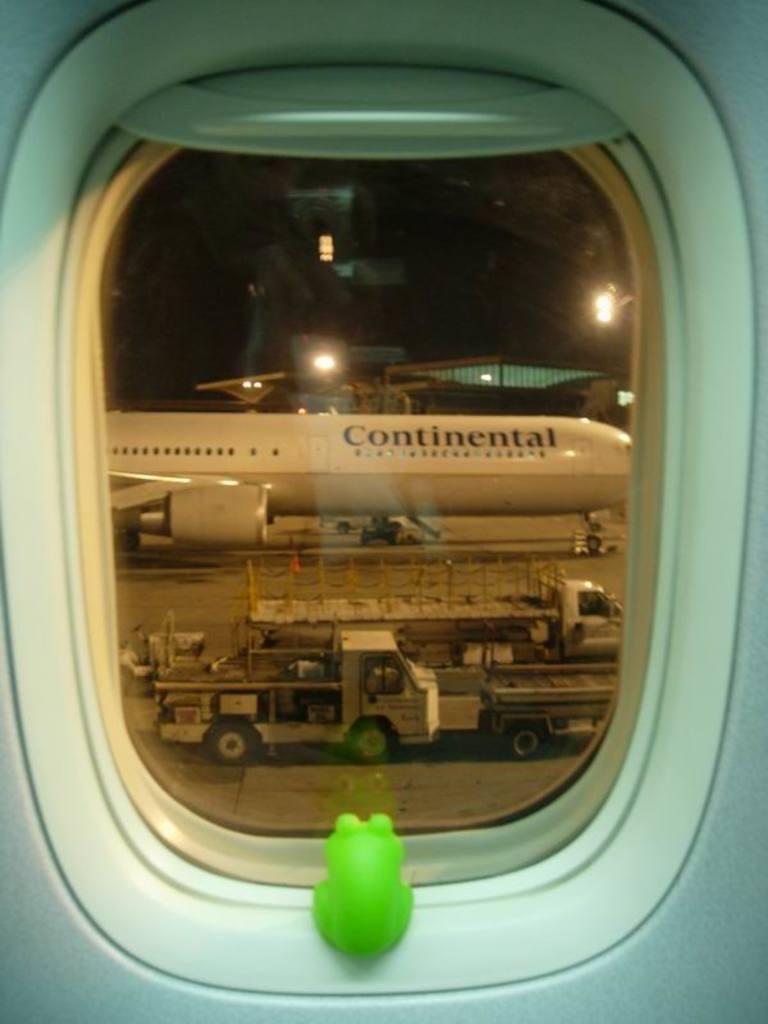Describe this image in one or two sentences. This is a picture taken from inside the airplane. Here I can see a glass window through which we can see the outside view. Beside there is a green color toy frog. In the outside view there is an aeroplane on the ground and also I can see few vehicles. In the background there are few lights in the dark. 